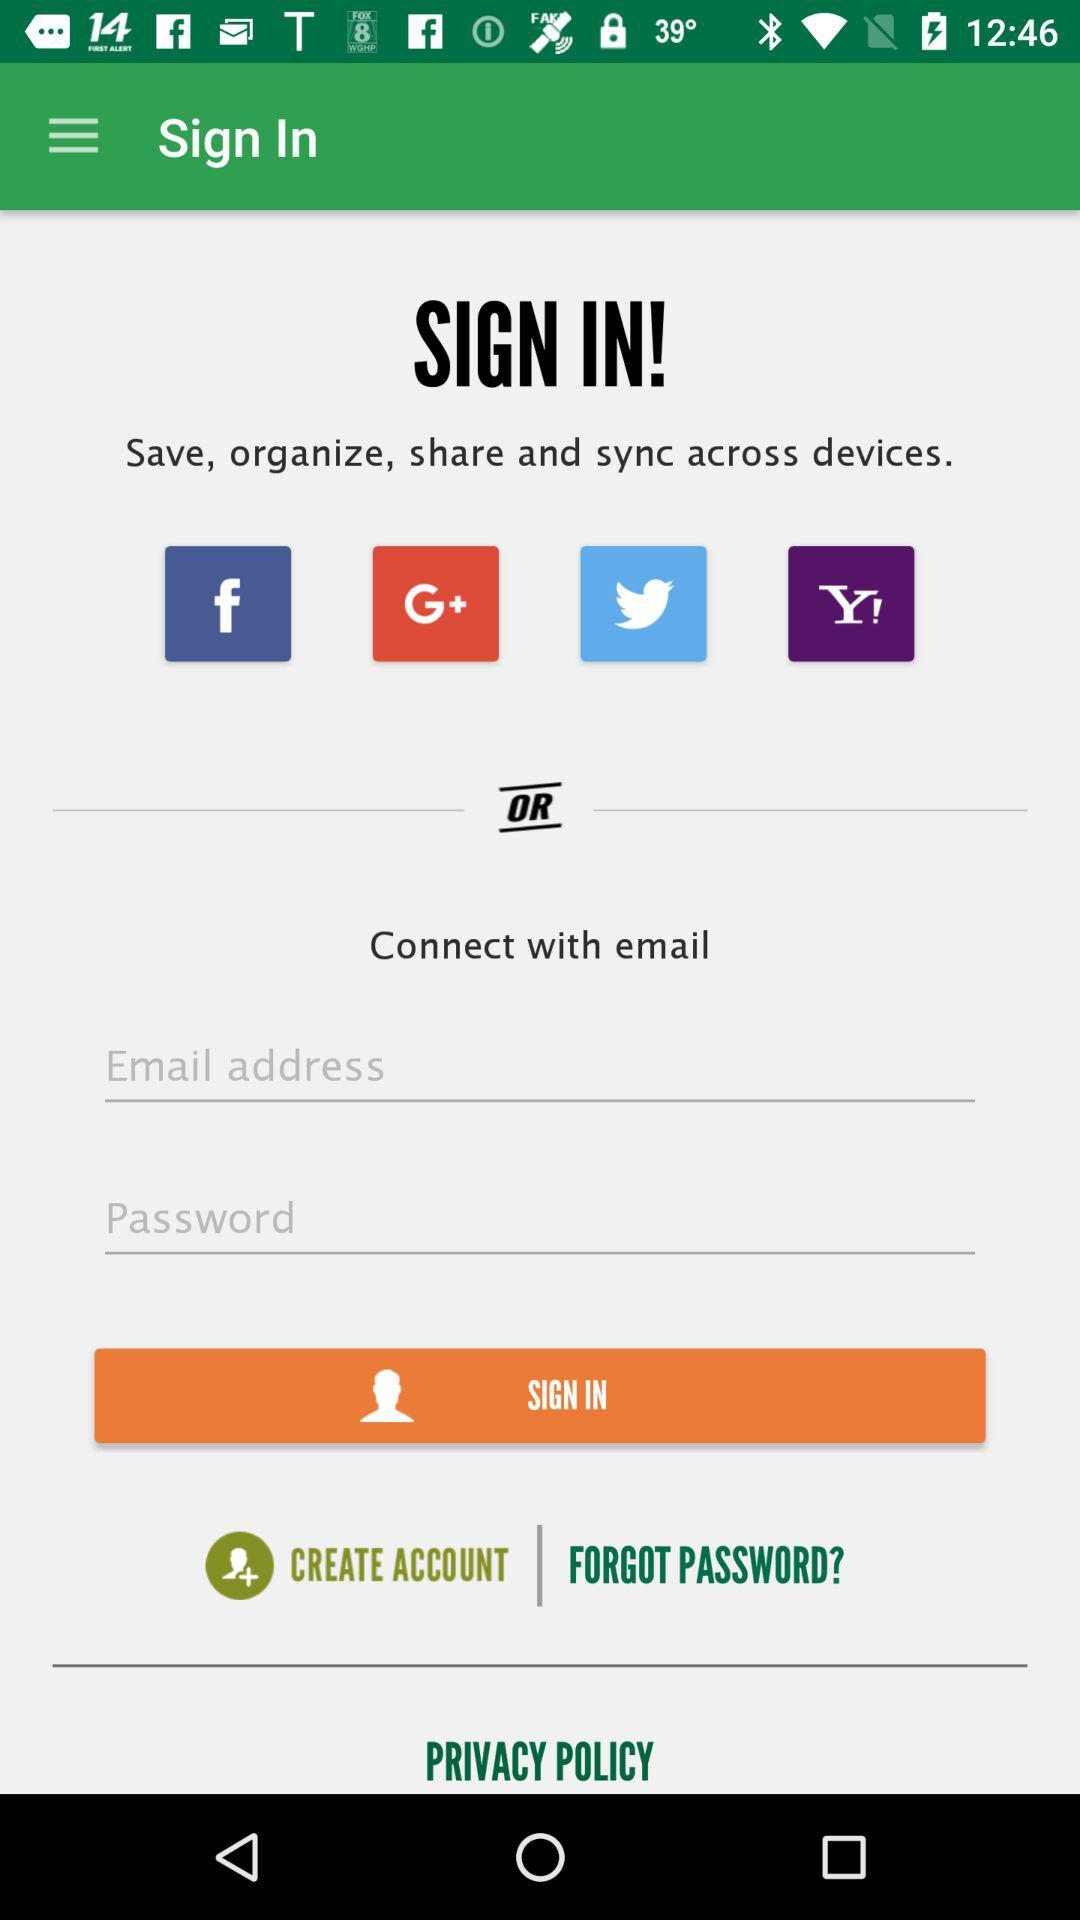Which accounts can I use to sign in? You can use "Facebook", "Google+", "Twitter" and "Yahoo" accounts to sign in. 